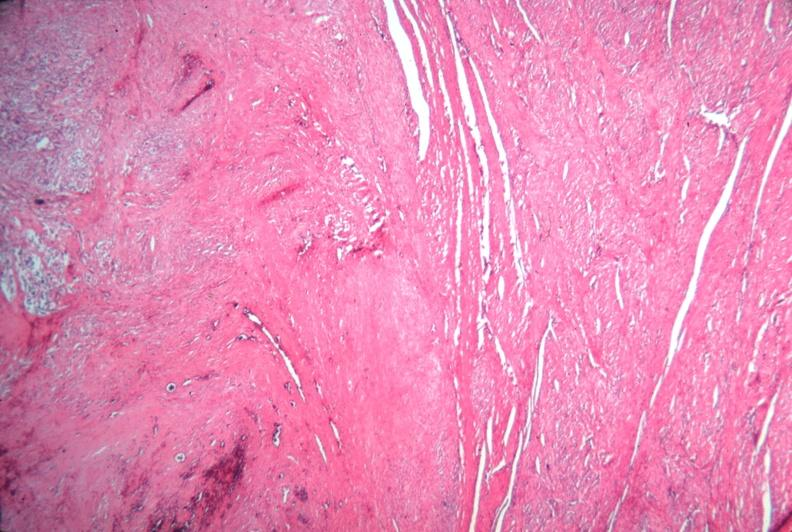what is present?
Answer the question using a single word or phrase. Female reproductive 